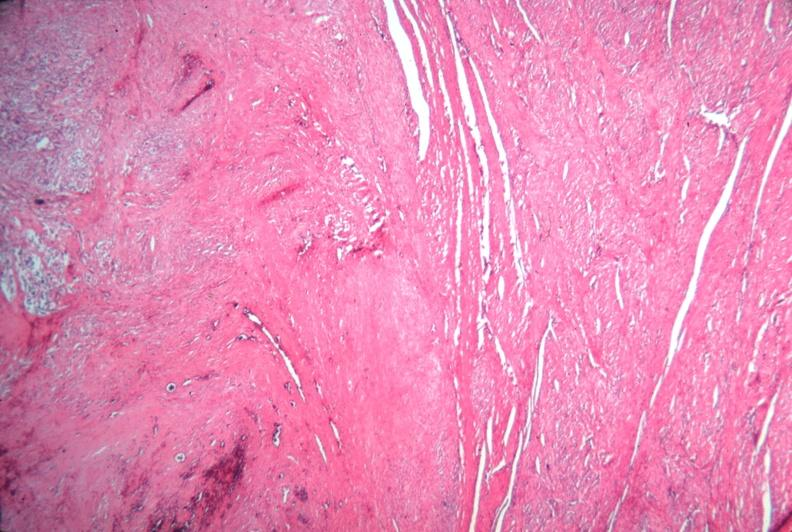what is present?
Answer the question using a single word or phrase. Female reproductive 